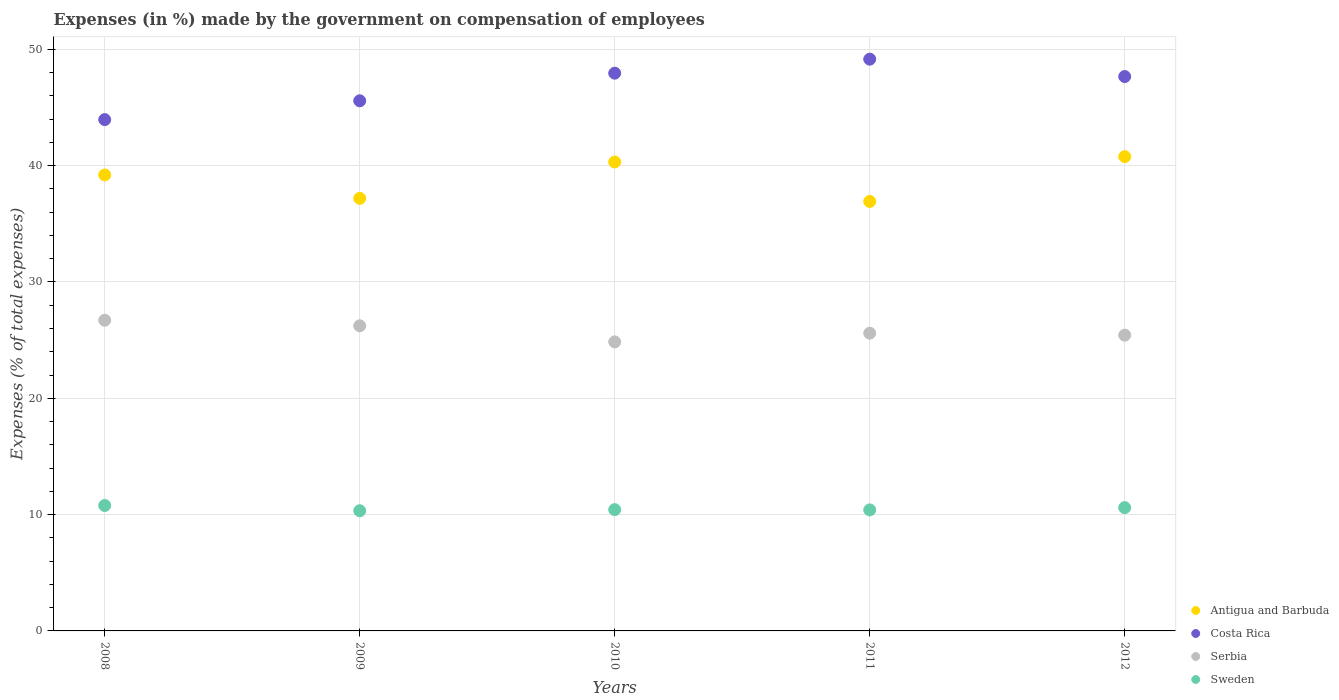What is the percentage of expenses made by the government on compensation of employees in Costa Rica in 2010?
Make the answer very short. 47.95. Across all years, what is the maximum percentage of expenses made by the government on compensation of employees in Sweden?
Offer a very short reply. 10.78. Across all years, what is the minimum percentage of expenses made by the government on compensation of employees in Antigua and Barbuda?
Offer a very short reply. 36.92. In which year was the percentage of expenses made by the government on compensation of employees in Costa Rica maximum?
Offer a very short reply. 2011. In which year was the percentage of expenses made by the government on compensation of employees in Costa Rica minimum?
Make the answer very short. 2008. What is the total percentage of expenses made by the government on compensation of employees in Sweden in the graph?
Provide a succinct answer. 52.55. What is the difference between the percentage of expenses made by the government on compensation of employees in Serbia in 2008 and that in 2009?
Your answer should be very brief. 0.48. What is the difference between the percentage of expenses made by the government on compensation of employees in Costa Rica in 2009 and the percentage of expenses made by the government on compensation of employees in Antigua and Barbuda in 2010?
Make the answer very short. 5.26. What is the average percentage of expenses made by the government on compensation of employees in Antigua and Barbuda per year?
Your response must be concise. 38.88. In the year 2012, what is the difference between the percentage of expenses made by the government on compensation of employees in Costa Rica and percentage of expenses made by the government on compensation of employees in Sweden?
Make the answer very short. 37.06. What is the ratio of the percentage of expenses made by the government on compensation of employees in Antigua and Barbuda in 2008 to that in 2012?
Offer a very short reply. 0.96. What is the difference between the highest and the second highest percentage of expenses made by the government on compensation of employees in Costa Rica?
Offer a terse response. 1.21. What is the difference between the highest and the lowest percentage of expenses made by the government on compensation of employees in Costa Rica?
Offer a very short reply. 5.2. Is the sum of the percentage of expenses made by the government on compensation of employees in Sweden in 2008 and 2010 greater than the maximum percentage of expenses made by the government on compensation of employees in Costa Rica across all years?
Ensure brevity in your answer.  No. Is it the case that in every year, the sum of the percentage of expenses made by the government on compensation of employees in Antigua and Barbuda and percentage of expenses made by the government on compensation of employees in Sweden  is greater than the percentage of expenses made by the government on compensation of employees in Costa Rica?
Give a very brief answer. No. Does the percentage of expenses made by the government on compensation of employees in Costa Rica monotonically increase over the years?
Your answer should be very brief. No. How many dotlines are there?
Offer a very short reply. 4. How many years are there in the graph?
Your response must be concise. 5. Are the values on the major ticks of Y-axis written in scientific E-notation?
Offer a very short reply. No. Does the graph contain any zero values?
Give a very brief answer. No. Where does the legend appear in the graph?
Offer a very short reply. Bottom right. How many legend labels are there?
Your answer should be compact. 4. How are the legend labels stacked?
Keep it short and to the point. Vertical. What is the title of the graph?
Ensure brevity in your answer.  Expenses (in %) made by the government on compensation of employees. Does "St. Lucia" appear as one of the legend labels in the graph?
Offer a terse response. No. What is the label or title of the X-axis?
Your response must be concise. Years. What is the label or title of the Y-axis?
Offer a terse response. Expenses (% of total expenses). What is the Expenses (% of total expenses) of Antigua and Barbuda in 2008?
Keep it short and to the point. 39.2. What is the Expenses (% of total expenses) of Costa Rica in 2008?
Your answer should be compact. 43.96. What is the Expenses (% of total expenses) of Serbia in 2008?
Your response must be concise. 26.71. What is the Expenses (% of total expenses) of Sweden in 2008?
Your answer should be compact. 10.78. What is the Expenses (% of total expenses) in Antigua and Barbuda in 2009?
Provide a succinct answer. 37.19. What is the Expenses (% of total expenses) in Costa Rica in 2009?
Provide a succinct answer. 45.58. What is the Expenses (% of total expenses) of Serbia in 2009?
Offer a very short reply. 26.23. What is the Expenses (% of total expenses) in Sweden in 2009?
Ensure brevity in your answer.  10.33. What is the Expenses (% of total expenses) in Antigua and Barbuda in 2010?
Give a very brief answer. 40.31. What is the Expenses (% of total expenses) in Costa Rica in 2010?
Provide a succinct answer. 47.95. What is the Expenses (% of total expenses) of Serbia in 2010?
Give a very brief answer. 24.85. What is the Expenses (% of total expenses) in Sweden in 2010?
Ensure brevity in your answer.  10.43. What is the Expenses (% of total expenses) in Antigua and Barbuda in 2011?
Make the answer very short. 36.92. What is the Expenses (% of total expenses) of Costa Rica in 2011?
Make the answer very short. 49.16. What is the Expenses (% of total expenses) in Serbia in 2011?
Provide a succinct answer. 25.6. What is the Expenses (% of total expenses) of Sweden in 2011?
Your response must be concise. 10.4. What is the Expenses (% of total expenses) of Antigua and Barbuda in 2012?
Your response must be concise. 40.77. What is the Expenses (% of total expenses) in Costa Rica in 2012?
Offer a terse response. 47.66. What is the Expenses (% of total expenses) in Serbia in 2012?
Give a very brief answer. 25.43. What is the Expenses (% of total expenses) in Sweden in 2012?
Offer a terse response. 10.6. Across all years, what is the maximum Expenses (% of total expenses) in Antigua and Barbuda?
Give a very brief answer. 40.77. Across all years, what is the maximum Expenses (% of total expenses) in Costa Rica?
Ensure brevity in your answer.  49.16. Across all years, what is the maximum Expenses (% of total expenses) of Serbia?
Give a very brief answer. 26.71. Across all years, what is the maximum Expenses (% of total expenses) in Sweden?
Make the answer very short. 10.78. Across all years, what is the minimum Expenses (% of total expenses) in Antigua and Barbuda?
Keep it short and to the point. 36.92. Across all years, what is the minimum Expenses (% of total expenses) in Costa Rica?
Keep it short and to the point. 43.96. Across all years, what is the minimum Expenses (% of total expenses) of Serbia?
Keep it short and to the point. 24.85. Across all years, what is the minimum Expenses (% of total expenses) of Sweden?
Make the answer very short. 10.33. What is the total Expenses (% of total expenses) of Antigua and Barbuda in the graph?
Provide a short and direct response. 194.4. What is the total Expenses (% of total expenses) of Costa Rica in the graph?
Provide a succinct answer. 234.3. What is the total Expenses (% of total expenses) of Serbia in the graph?
Offer a very short reply. 128.81. What is the total Expenses (% of total expenses) in Sweden in the graph?
Your answer should be very brief. 52.55. What is the difference between the Expenses (% of total expenses) in Antigua and Barbuda in 2008 and that in 2009?
Offer a very short reply. 2.01. What is the difference between the Expenses (% of total expenses) in Costa Rica in 2008 and that in 2009?
Ensure brevity in your answer.  -1.62. What is the difference between the Expenses (% of total expenses) in Serbia in 2008 and that in 2009?
Your answer should be very brief. 0.48. What is the difference between the Expenses (% of total expenses) of Sweden in 2008 and that in 2009?
Your answer should be compact. 0.45. What is the difference between the Expenses (% of total expenses) of Antigua and Barbuda in 2008 and that in 2010?
Ensure brevity in your answer.  -1.11. What is the difference between the Expenses (% of total expenses) in Costa Rica in 2008 and that in 2010?
Your answer should be very brief. -3.99. What is the difference between the Expenses (% of total expenses) in Serbia in 2008 and that in 2010?
Give a very brief answer. 1.86. What is the difference between the Expenses (% of total expenses) of Sweden in 2008 and that in 2010?
Provide a succinct answer. 0.36. What is the difference between the Expenses (% of total expenses) in Antigua and Barbuda in 2008 and that in 2011?
Give a very brief answer. 2.28. What is the difference between the Expenses (% of total expenses) in Costa Rica in 2008 and that in 2011?
Offer a terse response. -5.2. What is the difference between the Expenses (% of total expenses) of Serbia in 2008 and that in 2011?
Keep it short and to the point. 1.11. What is the difference between the Expenses (% of total expenses) of Sweden in 2008 and that in 2011?
Give a very brief answer. 0.38. What is the difference between the Expenses (% of total expenses) of Antigua and Barbuda in 2008 and that in 2012?
Provide a short and direct response. -1.57. What is the difference between the Expenses (% of total expenses) of Costa Rica in 2008 and that in 2012?
Keep it short and to the point. -3.7. What is the difference between the Expenses (% of total expenses) of Serbia in 2008 and that in 2012?
Keep it short and to the point. 1.28. What is the difference between the Expenses (% of total expenses) in Sweden in 2008 and that in 2012?
Your response must be concise. 0.18. What is the difference between the Expenses (% of total expenses) in Antigua and Barbuda in 2009 and that in 2010?
Ensure brevity in your answer.  -3.13. What is the difference between the Expenses (% of total expenses) of Costa Rica in 2009 and that in 2010?
Your response must be concise. -2.38. What is the difference between the Expenses (% of total expenses) of Serbia in 2009 and that in 2010?
Keep it short and to the point. 1.38. What is the difference between the Expenses (% of total expenses) of Sweden in 2009 and that in 2010?
Ensure brevity in your answer.  -0.1. What is the difference between the Expenses (% of total expenses) of Antigua and Barbuda in 2009 and that in 2011?
Keep it short and to the point. 0.26. What is the difference between the Expenses (% of total expenses) in Costa Rica in 2009 and that in 2011?
Provide a short and direct response. -3.58. What is the difference between the Expenses (% of total expenses) of Serbia in 2009 and that in 2011?
Offer a terse response. 0.64. What is the difference between the Expenses (% of total expenses) in Sweden in 2009 and that in 2011?
Your answer should be very brief. -0.07. What is the difference between the Expenses (% of total expenses) of Antigua and Barbuda in 2009 and that in 2012?
Your answer should be very brief. -3.59. What is the difference between the Expenses (% of total expenses) of Costa Rica in 2009 and that in 2012?
Make the answer very short. -2.08. What is the difference between the Expenses (% of total expenses) in Serbia in 2009 and that in 2012?
Provide a succinct answer. 0.81. What is the difference between the Expenses (% of total expenses) of Sweden in 2009 and that in 2012?
Provide a succinct answer. -0.27. What is the difference between the Expenses (% of total expenses) of Antigua and Barbuda in 2010 and that in 2011?
Provide a short and direct response. 3.39. What is the difference between the Expenses (% of total expenses) in Costa Rica in 2010 and that in 2011?
Give a very brief answer. -1.21. What is the difference between the Expenses (% of total expenses) of Serbia in 2010 and that in 2011?
Your answer should be compact. -0.75. What is the difference between the Expenses (% of total expenses) in Sweden in 2010 and that in 2011?
Offer a terse response. 0.02. What is the difference between the Expenses (% of total expenses) of Antigua and Barbuda in 2010 and that in 2012?
Offer a terse response. -0.46. What is the difference between the Expenses (% of total expenses) of Costa Rica in 2010 and that in 2012?
Offer a very short reply. 0.29. What is the difference between the Expenses (% of total expenses) of Serbia in 2010 and that in 2012?
Offer a terse response. -0.58. What is the difference between the Expenses (% of total expenses) of Sweden in 2010 and that in 2012?
Your answer should be compact. -0.17. What is the difference between the Expenses (% of total expenses) of Antigua and Barbuda in 2011 and that in 2012?
Make the answer very short. -3.85. What is the difference between the Expenses (% of total expenses) in Costa Rica in 2011 and that in 2012?
Provide a short and direct response. 1.5. What is the difference between the Expenses (% of total expenses) of Serbia in 2011 and that in 2012?
Ensure brevity in your answer.  0.17. What is the difference between the Expenses (% of total expenses) of Sweden in 2011 and that in 2012?
Your answer should be very brief. -0.2. What is the difference between the Expenses (% of total expenses) of Antigua and Barbuda in 2008 and the Expenses (% of total expenses) of Costa Rica in 2009?
Keep it short and to the point. -6.37. What is the difference between the Expenses (% of total expenses) of Antigua and Barbuda in 2008 and the Expenses (% of total expenses) of Serbia in 2009?
Give a very brief answer. 12.97. What is the difference between the Expenses (% of total expenses) of Antigua and Barbuda in 2008 and the Expenses (% of total expenses) of Sweden in 2009?
Give a very brief answer. 28.87. What is the difference between the Expenses (% of total expenses) in Costa Rica in 2008 and the Expenses (% of total expenses) in Serbia in 2009?
Your answer should be very brief. 17.73. What is the difference between the Expenses (% of total expenses) of Costa Rica in 2008 and the Expenses (% of total expenses) of Sweden in 2009?
Provide a short and direct response. 33.63. What is the difference between the Expenses (% of total expenses) in Serbia in 2008 and the Expenses (% of total expenses) in Sweden in 2009?
Offer a terse response. 16.37. What is the difference between the Expenses (% of total expenses) in Antigua and Barbuda in 2008 and the Expenses (% of total expenses) in Costa Rica in 2010?
Your answer should be very brief. -8.75. What is the difference between the Expenses (% of total expenses) of Antigua and Barbuda in 2008 and the Expenses (% of total expenses) of Serbia in 2010?
Provide a short and direct response. 14.35. What is the difference between the Expenses (% of total expenses) in Antigua and Barbuda in 2008 and the Expenses (% of total expenses) in Sweden in 2010?
Your answer should be compact. 28.77. What is the difference between the Expenses (% of total expenses) of Costa Rica in 2008 and the Expenses (% of total expenses) of Serbia in 2010?
Offer a terse response. 19.11. What is the difference between the Expenses (% of total expenses) in Costa Rica in 2008 and the Expenses (% of total expenses) in Sweden in 2010?
Make the answer very short. 33.53. What is the difference between the Expenses (% of total expenses) of Serbia in 2008 and the Expenses (% of total expenses) of Sweden in 2010?
Ensure brevity in your answer.  16.28. What is the difference between the Expenses (% of total expenses) in Antigua and Barbuda in 2008 and the Expenses (% of total expenses) in Costa Rica in 2011?
Provide a succinct answer. -9.95. What is the difference between the Expenses (% of total expenses) in Antigua and Barbuda in 2008 and the Expenses (% of total expenses) in Serbia in 2011?
Your answer should be very brief. 13.6. What is the difference between the Expenses (% of total expenses) of Antigua and Barbuda in 2008 and the Expenses (% of total expenses) of Sweden in 2011?
Ensure brevity in your answer.  28.8. What is the difference between the Expenses (% of total expenses) of Costa Rica in 2008 and the Expenses (% of total expenses) of Serbia in 2011?
Keep it short and to the point. 18.36. What is the difference between the Expenses (% of total expenses) of Costa Rica in 2008 and the Expenses (% of total expenses) of Sweden in 2011?
Make the answer very short. 33.55. What is the difference between the Expenses (% of total expenses) in Serbia in 2008 and the Expenses (% of total expenses) in Sweden in 2011?
Make the answer very short. 16.3. What is the difference between the Expenses (% of total expenses) of Antigua and Barbuda in 2008 and the Expenses (% of total expenses) of Costa Rica in 2012?
Provide a short and direct response. -8.46. What is the difference between the Expenses (% of total expenses) of Antigua and Barbuda in 2008 and the Expenses (% of total expenses) of Serbia in 2012?
Provide a succinct answer. 13.77. What is the difference between the Expenses (% of total expenses) of Antigua and Barbuda in 2008 and the Expenses (% of total expenses) of Sweden in 2012?
Your response must be concise. 28.6. What is the difference between the Expenses (% of total expenses) in Costa Rica in 2008 and the Expenses (% of total expenses) in Serbia in 2012?
Provide a succinct answer. 18.53. What is the difference between the Expenses (% of total expenses) in Costa Rica in 2008 and the Expenses (% of total expenses) in Sweden in 2012?
Make the answer very short. 33.36. What is the difference between the Expenses (% of total expenses) of Serbia in 2008 and the Expenses (% of total expenses) of Sweden in 2012?
Offer a terse response. 16.11. What is the difference between the Expenses (% of total expenses) of Antigua and Barbuda in 2009 and the Expenses (% of total expenses) of Costa Rica in 2010?
Give a very brief answer. -10.76. What is the difference between the Expenses (% of total expenses) in Antigua and Barbuda in 2009 and the Expenses (% of total expenses) in Serbia in 2010?
Give a very brief answer. 12.34. What is the difference between the Expenses (% of total expenses) in Antigua and Barbuda in 2009 and the Expenses (% of total expenses) in Sweden in 2010?
Keep it short and to the point. 26.76. What is the difference between the Expenses (% of total expenses) of Costa Rica in 2009 and the Expenses (% of total expenses) of Serbia in 2010?
Keep it short and to the point. 20.73. What is the difference between the Expenses (% of total expenses) in Costa Rica in 2009 and the Expenses (% of total expenses) in Sweden in 2010?
Offer a terse response. 35.15. What is the difference between the Expenses (% of total expenses) in Serbia in 2009 and the Expenses (% of total expenses) in Sweden in 2010?
Keep it short and to the point. 15.8. What is the difference between the Expenses (% of total expenses) of Antigua and Barbuda in 2009 and the Expenses (% of total expenses) of Costa Rica in 2011?
Your response must be concise. -11.97. What is the difference between the Expenses (% of total expenses) of Antigua and Barbuda in 2009 and the Expenses (% of total expenses) of Serbia in 2011?
Give a very brief answer. 11.59. What is the difference between the Expenses (% of total expenses) in Antigua and Barbuda in 2009 and the Expenses (% of total expenses) in Sweden in 2011?
Your answer should be very brief. 26.78. What is the difference between the Expenses (% of total expenses) in Costa Rica in 2009 and the Expenses (% of total expenses) in Serbia in 2011?
Keep it short and to the point. 19.98. What is the difference between the Expenses (% of total expenses) in Costa Rica in 2009 and the Expenses (% of total expenses) in Sweden in 2011?
Your response must be concise. 35.17. What is the difference between the Expenses (% of total expenses) in Serbia in 2009 and the Expenses (% of total expenses) in Sweden in 2011?
Provide a short and direct response. 15.83. What is the difference between the Expenses (% of total expenses) in Antigua and Barbuda in 2009 and the Expenses (% of total expenses) in Costa Rica in 2012?
Offer a terse response. -10.47. What is the difference between the Expenses (% of total expenses) in Antigua and Barbuda in 2009 and the Expenses (% of total expenses) in Serbia in 2012?
Your answer should be very brief. 11.76. What is the difference between the Expenses (% of total expenses) of Antigua and Barbuda in 2009 and the Expenses (% of total expenses) of Sweden in 2012?
Keep it short and to the point. 26.59. What is the difference between the Expenses (% of total expenses) in Costa Rica in 2009 and the Expenses (% of total expenses) in Serbia in 2012?
Give a very brief answer. 20.15. What is the difference between the Expenses (% of total expenses) of Costa Rica in 2009 and the Expenses (% of total expenses) of Sweden in 2012?
Provide a short and direct response. 34.97. What is the difference between the Expenses (% of total expenses) of Serbia in 2009 and the Expenses (% of total expenses) of Sweden in 2012?
Keep it short and to the point. 15.63. What is the difference between the Expenses (% of total expenses) of Antigua and Barbuda in 2010 and the Expenses (% of total expenses) of Costa Rica in 2011?
Your answer should be compact. -8.84. What is the difference between the Expenses (% of total expenses) of Antigua and Barbuda in 2010 and the Expenses (% of total expenses) of Serbia in 2011?
Offer a very short reply. 14.72. What is the difference between the Expenses (% of total expenses) in Antigua and Barbuda in 2010 and the Expenses (% of total expenses) in Sweden in 2011?
Your answer should be compact. 29.91. What is the difference between the Expenses (% of total expenses) in Costa Rica in 2010 and the Expenses (% of total expenses) in Serbia in 2011?
Your response must be concise. 22.35. What is the difference between the Expenses (% of total expenses) in Costa Rica in 2010 and the Expenses (% of total expenses) in Sweden in 2011?
Your answer should be compact. 37.55. What is the difference between the Expenses (% of total expenses) in Serbia in 2010 and the Expenses (% of total expenses) in Sweden in 2011?
Ensure brevity in your answer.  14.45. What is the difference between the Expenses (% of total expenses) of Antigua and Barbuda in 2010 and the Expenses (% of total expenses) of Costa Rica in 2012?
Ensure brevity in your answer.  -7.35. What is the difference between the Expenses (% of total expenses) of Antigua and Barbuda in 2010 and the Expenses (% of total expenses) of Serbia in 2012?
Give a very brief answer. 14.89. What is the difference between the Expenses (% of total expenses) in Antigua and Barbuda in 2010 and the Expenses (% of total expenses) in Sweden in 2012?
Keep it short and to the point. 29.71. What is the difference between the Expenses (% of total expenses) in Costa Rica in 2010 and the Expenses (% of total expenses) in Serbia in 2012?
Offer a terse response. 22.52. What is the difference between the Expenses (% of total expenses) of Costa Rica in 2010 and the Expenses (% of total expenses) of Sweden in 2012?
Make the answer very short. 37.35. What is the difference between the Expenses (% of total expenses) in Serbia in 2010 and the Expenses (% of total expenses) in Sweden in 2012?
Provide a succinct answer. 14.25. What is the difference between the Expenses (% of total expenses) of Antigua and Barbuda in 2011 and the Expenses (% of total expenses) of Costa Rica in 2012?
Provide a short and direct response. -10.74. What is the difference between the Expenses (% of total expenses) in Antigua and Barbuda in 2011 and the Expenses (% of total expenses) in Serbia in 2012?
Provide a short and direct response. 11.5. What is the difference between the Expenses (% of total expenses) of Antigua and Barbuda in 2011 and the Expenses (% of total expenses) of Sweden in 2012?
Offer a very short reply. 26.32. What is the difference between the Expenses (% of total expenses) in Costa Rica in 2011 and the Expenses (% of total expenses) in Serbia in 2012?
Provide a short and direct response. 23.73. What is the difference between the Expenses (% of total expenses) of Costa Rica in 2011 and the Expenses (% of total expenses) of Sweden in 2012?
Your response must be concise. 38.55. What is the difference between the Expenses (% of total expenses) of Serbia in 2011 and the Expenses (% of total expenses) of Sweden in 2012?
Provide a short and direct response. 14.99. What is the average Expenses (% of total expenses) of Antigua and Barbuda per year?
Your answer should be compact. 38.88. What is the average Expenses (% of total expenses) in Costa Rica per year?
Make the answer very short. 46.86. What is the average Expenses (% of total expenses) in Serbia per year?
Your answer should be compact. 25.76. What is the average Expenses (% of total expenses) in Sweden per year?
Keep it short and to the point. 10.51. In the year 2008, what is the difference between the Expenses (% of total expenses) of Antigua and Barbuda and Expenses (% of total expenses) of Costa Rica?
Your response must be concise. -4.76. In the year 2008, what is the difference between the Expenses (% of total expenses) of Antigua and Barbuda and Expenses (% of total expenses) of Serbia?
Offer a very short reply. 12.49. In the year 2008, what is the difference between the Expenses (% of total expenses) in Antigua and Barbuda and Expenses (% of total expenses) in Sweden?
Provide a short and direct response. 28.42. In the year 2008, what is the difference between the Expenses (% of total expenses) in Costa Rica and Expenses (% of total expenses) in Serbia?
Give a very brief answer. 17.25. In the year 2008, what is the difference between the Expenses (% of total expenses) in Costa Rica and Expenses (% of total expenses) in Sweden?
Give a very brief answer. 33.17. In the year 2008, what is the difference between the Expenses (% of total expenses) in Serbia and Expenses (% of total expenses) in Sweden?
Your response must be concise. 15.92. In the year 2009, what is the difference between the Expenses (% of total expenses) in Antigua and Barbuda and Expenses (% of total expenses) in Costa Rica?
Your answer should be very brief. -8.39. In the year 2009, what is the difference between the Expenses (% of total expenses) in Antigua and Barbuda and Expenses (% of total expenses) in Serbia?
Provide a succinct answer. 10.96. In the year 2009, what is the difference between the Expenses (% of total expenses) of Antigua and Barbuda and Expenses (% of total expenses) of Sweden?
Your response must be concise. 26.86. In the year 2009, what is the difference between the Expenses (% of total expenses) of Costa Rica and Expenses (% of total expenses) of Serbia?
Provide a succinct answer. 19.34. In the year 2009, what is the difference between the Expenses (% of total expenses) of Costa Rica and Expenses (% of total expenses) of Sweden?
Keep it short and to the point. 35.24. In the year 2009, what is the difference between the Expenses (% of total expenses) of Serbia and Expenses (% of total expenses) of Sweden?
Your response must be concise. 15.9. In the year 2010, what is the difference between the Expenses (% of total expenses) of Antigua and Barbuda and Expenses (% of total expenses) of Costa Rica?
Provide a short and direct response. -7.64. In the year 2010, what is the difference between the Expenses (% of total expenses) in Antigua and Barbuda and Expenses (% of total expenses) in Serbia?
Offer a very short reply. 15.46. In the year 2010, what is the difference between the Expenses (% of total expenses) of Antigua and Barbuda and Expenses (% of total expenses) of Sweden?
Offer a very short reply. 29.89. In the year 2010, what is the difference between the Expenses (% of total expenses) in Costa Rica and Expenses (% of total expenses) in Serbia?
Your answer should be compact. 23.1. In the year 2010, what is the difference between the Expenses (% of total expenses) in Costa Rica and Expenses (% of total expenses) in Sweden?
Your response must be concise. 37.52. In the year 2010, what is the difference between the Expenses (% of total expenses) in Serbia and Expenses (% of total expenses) in Sweden?
Provide a succinct answer. 14.42. In the year 2011, what is the difference between the Expenses (% of total expenses) in Antigua and Barbuda and Expenses (% of total expenses) in Costa Rica?
Give a very brief answer. -12.23. In the year 2011, what is the difference between the Expenses (% of total expenses) in Antigua and Barbuda and Expenses (% of total expenses) in Serbia?
Keep it short and to the point. 11.33. In the year 2011, what is the difference between the Expenses (% of total expenses) in Antigua and Barbuda and Expenses (% of total expenses) in Sweden?
Make the answer very short. 26.52. In the year 2011, what is the difference between the Expenses (% of total expenses) in Costa Rica and Expenses (% of total expenses) in Serbia?
Your answer should be compact. 23.56. In the year 2011, what is the difference between the Expenses (% of total expenses) in Costa Rica and Expenses (% of total expenses) in Sweden?
Provide a succinct answer. 38.75. In the year 2011, what is the difference between the Expenses (% of total expenses) of Serbia and Expenses (% of total expenses) of Sweden?
Offer a very short reply. 15.19. In the year 2012, what is the difference between the Expenses (% of total expenses) in Antigua and Barbuda and Expenses (% of total expenses) in Costa Rica?
Your response must be concise. -6.89. In the year 2012, what is the difference between the Expenses (% of total expenses) in Antigua and Barbuda and Expenses (% of total expenses) in Serbia?
Ensure brevity in your answer.  15.35. In the year 2012, what is the difference between the Expenses (% of total expenses) in Antigua and Barbuda and Expenses (% of total expenses) in Sweden?
Offer a terse response. 30.17. In the year 2012, what is the difference between the Expenses (% of total expenses) of Costa Rica and Expenses (% of total expenses) of Serbia?
Offer a very short reply. 22.23. In the year 2012, what is the difference between the Expenses (% of total expenses) of Costa Rica and Expenses (% of total expenses) of Sweden?
Make the answer very short. 37.06. In the year 2012, what is the difference between the Expenses (% of total expenses) of Serbia and Expenses (% of total expenses) of Sweden?
Provide a succinct answer. 14.82. What is the ratio of the Expenses (% of total expenses) of Antigua and Barbuda in 2008 to that in 2009?
Your answer should be compact. 1.05. What is the ratio of the Expenses (% of total expenses) in Costa Rica in 2008 to that in 2009?
Give a very brief answer. 0.96. What is the ratio of the Expenses (% of total expenses) in Serbia in 2008 to that in 2009?
Your answer should be very brief. 1.02. What is the ratio of the Expenses (% of total expenses) in Sweden in 2008 to that in 2009?
Offer a very short reply. 1.04. What is the ratio of the Expenses (% of total expenses) in Antigua and Barbuda in 2008 to that in 2010?
Your answer should be compact. 0.97. What is the ratio of the Expenses (% of total expenses) of Costa Rica in 2008 to that in 2010?
Your answer should be compact. 0.92. What is the ratio of the Expenses (% of total expenses) in Serbia in 2008 to that in 2010?
Provide a short and direct response. 1.07. What is the ratio of the Expenses (% of total expenses) of Sweden in 2008 to that in 2010?
Your response must be concise. 1.03. What is the ratio of the Expenses (% of total expenses) of Antigua and Barbuda in 2008 to that in 2011?
Provide a succinct answer. 1.06. What is the ratio of the Expenses (% of total expenses) of Costa Rica in 2008 to that in 2011?
Your answer should be compact. 0.89. What is the ratio of the Expenses (% of total expenses) of Serbia in 2008 to that in 2011?
Offer a very short reply. 1.04. What is the ratio of the Expenses (% of total expenses) in Sweden in 2008 to that in 2011?
Offer a very short reply. 1.04. What is the ratio of the Expenses (% of total expenses) of Antigua and Barbuda in 2008 to that in 2012?
Your response must be concise. 0.96. What is the ratio of the Expenses (% of total expenses) of Costa Rica in 2008 to that in 2012?
Keep it short and to the point. 0.92. What is the ratio of the Expenses (% of total expenses) of Serbia in 2008 to that in 2012?
Your answer should be compact. 1.05. What is the ratio of the Expenses (% of total expenses) in Sweden in 2008 to that in 2012?
Ensure brevity in your answer.  1.02. What is the ratio of the Expenses (% of total expenses) of Antigua and Barbuda in 2009 to that in 2010?
Your response must be concise. 0.92. What is the ratio of the Expenses (% of total expenses) in Costa Rica in 2009 to that in 2010?
Give a very brief answer. 0.95. What is the ratio of the Expenses (% of total expenses) in Serbia in 2009 to that in 2010?
Your answer should be compact. 1.06. What is the ratio of the Expenses (% of total expenses) in Sweden in 2009 to that in 2010?
Give a very brief answer. 0.99. What is the ratio of the Expenses (% of total expenses) of Antigua and Barbuda in 2009 to that in 2011?
Ensure brevity in your answer.  1.01. What is the ratio of the Expenses (% of total expenses) of Costa Rica in 2009 to that in 2011?
Ensure brevity in your answer.  0.93. What is the ratio of the Expenses (% of total expenses) in Serbia in 2009 to that in 2011?
Provide a succinct answer. 1.02. What is the ratio of the Expenses (% of total expenses) in Sweden in 2009 to that in 2011?
Give a very brief answer. 0.99. What is the ratio of the Expenses (% of total expenses) of Antigua and Barbuda in 2009 to that in 2012?
Offer a very short reply. 0.91. What is the ratio of the Expenses (% of total expenses) in Costa Rica in 2009 to that in 2012?
Your answer should be very brief. 0.96. What is the ratio of the Expenses (% of total expenses) in Serbia in 2009 to that in 2012?
Offer a terse response. 1.03. What is the ratio of the Expenses (% of total expenses) in Sweden in 2009 to that in 2012?
Give a very brief answer. 0.97. What is the ratio of the Expenses (% of total expenses) of Antigua and Barbuda in 2010 to that in 2011?
Provide a short and direct response. 1.09. What is the ratio of the Expenses (% of total expenses) of Costa Rica in 2010 to that in 2011?
Make the answer very short. 0.98. What is the ratio of the Expenses (% of total expenses) of Serbia in 2010 to that in 2011?
Keep it short and to the point. 0.97. What is the ratio of the Expenses (% of total expenses) in Antigua and Barbuda in 2010 to that in 2012?
Provide a short and direct response. 0.99. What is the ratio of the Expenses (% of total expenses) of Serbia in 2010 to that in 2012?
Ensure brevity in your answer.  0.98. What is the ratio of the Expenses (% of total expenses) in Sweden in 2010 to that in 2012?
Provide a short and direct response. 0.98. What is the ratio of the Expenses (% of total expenses) in Antigua and Barbuda in 2011 to that in 2012?
Your response must be concise. 0.91. What is the ratio of the Expenses (% of total expenses) of Costa Rica in 2011 to that in 2012?
Your answer should be very brief. 1.03. What is the ratio of the Expenses (% of total expenses) of Sweden in 2011 to that in 2012?
Your answer should be very brief. 0.98. What is the difference between the highest and the second highest Expenses (% of total expenses) in Antigua and Barbuda?
Keep it short and to the point. 0.46. What is the difference between the highest and the second highest Expenses (% of total expenses) in Costa Rica?
Provide a succinct answer. 1.21. What is the difference between the highest and the second highest Expenses (% of total expenses) of Serbia?
Offer a terse response. 0.48. What is the difference between the highest and the second highest Expenses (% of total expenses) of Sweden?
Your answer should be very brief. 0.18. What is the difference between the highest and the lowest Expenses (% of total expenses) in Antigua and Barbuda?
Give a very brief answer. 3.85. What is the difference between the highest and the lowest Expenses (% of total expenses) of Costa Rica?
Provide a short and direct response. 5.2. What is the difference between the highest and the lowest Expenses (% of total expenses) of Serbia?
Provide a succinct answer. 1.86. What is the difference between the highest and the lowest Expenses (% of total expenses) of Sweden?
Offer a terse response. 0.45. 